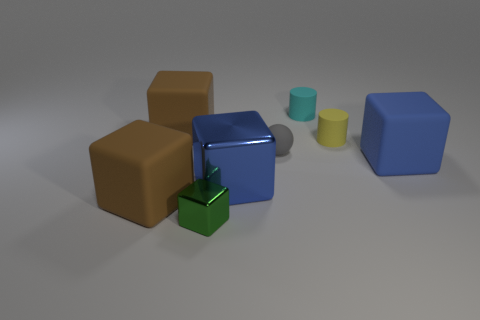How many objects are large blocks to the left of the large blue shiny thing or rubber things that are on the left side of the tiny yellow matte cylinder?
Give a very brief answer. 4. Does the large blue cube on the right side of the gray matte ball have the same material as the cyan object?
Make the answer very short. Yes. What is the material of the large thing that is on the right side of the tiny block and left of the small cyan rubber cylinder?
Offer a very short reply. Metal. What color is the matte cube right of the shiny cube behind the tiny metallic cube?
Ensure brevity in your answer.  Blue. There is a green object that is the same shape as the large blue shiny thing; what is it made of?
Keep it short and to the point. Metal. The small rubber cylinder that is in front of the big rubber object behind the tiny gray matte object that is behind the tiny metallic block is what color?
Your answer should be very brief. Yellow. What number of things are either tiny cyan metal balls or big brown rubber blocks?
Offer a terse response. 2. How many other tiny gray things have the same shape as the gray matte thing?
Offer a very short reply. 0. Is the material of the tiny gray thing the same as the brown thing behind the tiny yellow rubber thing?
Give a very brief answer. Yes. There is a blue block that is made of the same material as the small cyan thing; what size is it?
Offer a terse response. Large. 